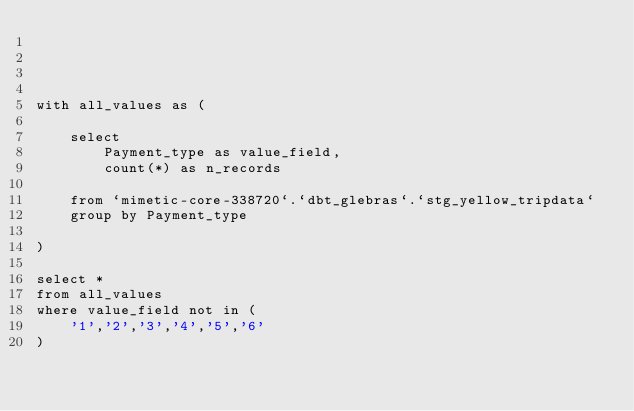<code> <loc_0><loc_0><loc_500><loc_500><_SQL_>
    
    

with all_values as (

    select
        Payment_type as value_field,
        count(*) as n_records

    from `mimetic-core-338720`.`dbt_glebras`.`stg_yellow_tripdata`
    group by Payment_type

)

select *
from all_values
where value_field not in (
    '1','2','3','4','5','6'
)


</code> 